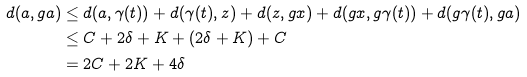<formula> <loc_0><loc_0><loc_500><loc_500>d ( a , g a ) & \leq d ( a , \gamma ( t ) ) + d ( \gamma ( t ) , z ) + d ( z , g x ) + d ( g x , g \gamma ( t ) ) + d ( g \gamma ( t ) , g a ) \\ & \leq C + 2 \delta + K + ( 2 \delta + K ) + C \\ & = 2 C + 2 K + 4 \delta</formula> 